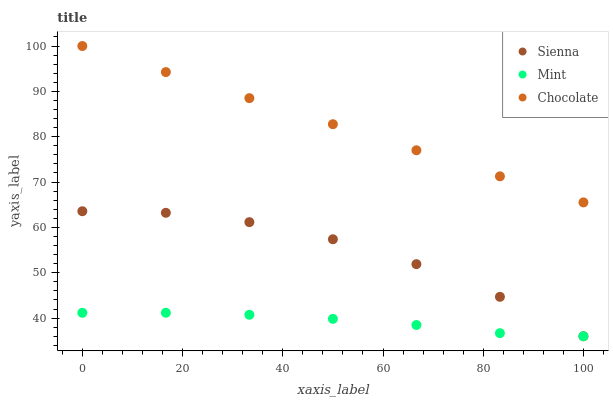Does Mint have the minimum area under the curve?
Answer yes or no. Yes. Does Chocolate have the maximum area under the curve?
Answer yes or no. Yes. Does Chocolate have the minimum area under the curve?
Answer yes or no. No. Does Mint have the maximum area under the curve?
Answer yes or no. No. Is Chocolate the smoothest?
Answer yes or no. Yes. Is Sienna the roughest?
Answer yes or no. Yes. Is Mint the smoothest?
Answer yes or no. No. Is Mint the roughest?
Answer yes or no. No. Does Sienna have the lowest value?
Answer yes or no. Yes. Does Chocolate have the lowest value?
Answer yes or no. No. Does Chocolate have the highest value?
Answer yes or no. Yes. Does Mint have the highest value?
Answer yes or no. No. Is Mint less than Chocolate?
Answer yes or no. Yes. Is Chocolate greater than Mint?
Answer yes or no. Yes. Does Mint intersect Sienna?
Answer yes or no. Yes. Is Mint less than Sienna?
Answer yes or no. No. Is Mint greater than Sienna?
Answer yes or no. No. Does Mint intersect Chocolate?
Answer yes or no. No. 